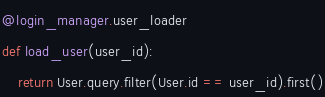Convert code to text. <code><loc_0><loc_0><loc_500><loc_500><_Python_>

@login_manager.user_loader
def load_user(user_id):
    return User.query.filter(User.id == user_id).first()
</code> 